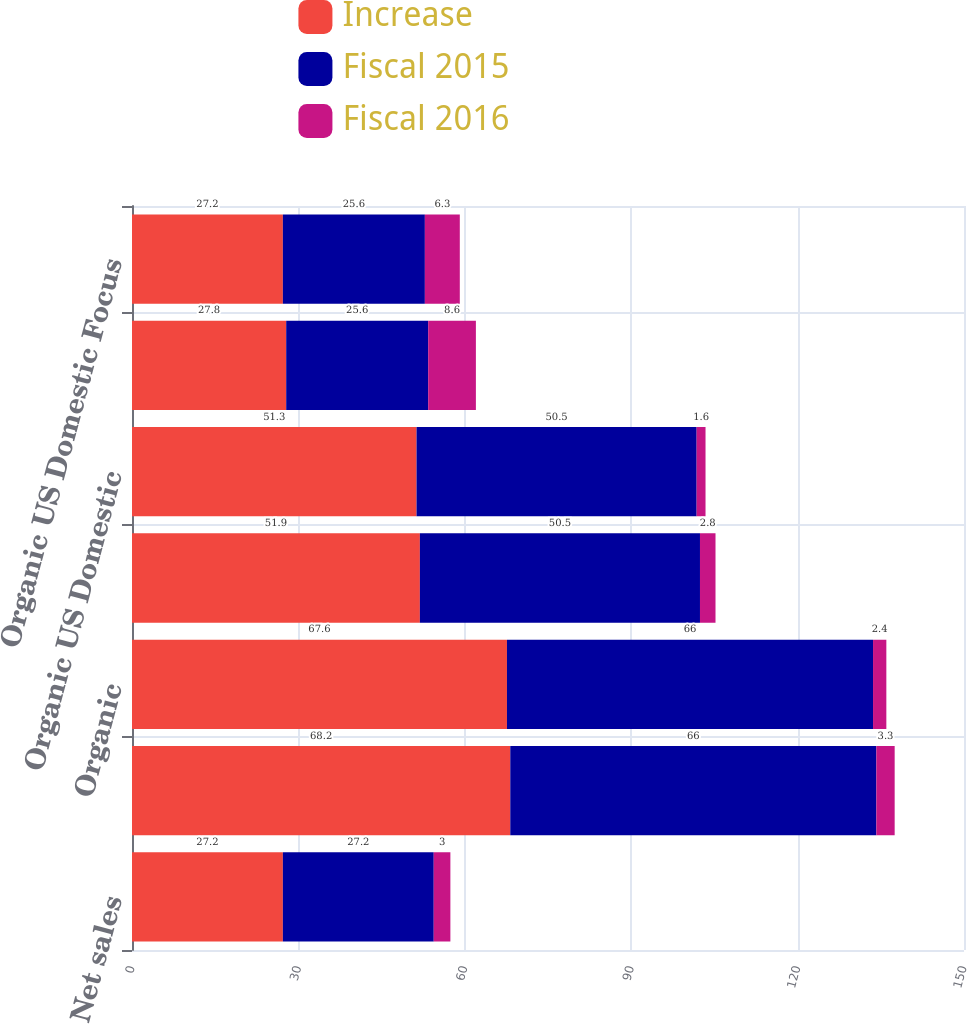Convert chart to OTSL. <chart><loc_0><loc_0><loc_500><loc_500><stacked_bar_chart><ecel><fcel>Net sales<fcel>Total<fcel>Organic<fcel>US Domestic<fcel>Organic US Domestic<fcel>US Domestic Focus Brands<fcel>Organic US Domestic Focus<nl><fcel>Increase<fcel>27.2<fcel>68.2<fcel>67.6<fcel>51.9<fcel>51.3<fcel>27.8<fcel>27.2<nl><fcel>Fiscal 2015<fcel>27.2<fcel>66<fcel>66<fcel>50.5<fcel>50.5<fcel>25.6<fcel>25.6<nl><fcel>Fiscal 2016<fcel>3<fcel>3.3<fcel>2.4<fcel>2.8<fcel>1.6<fcel>8.6<fcel>6.3<nl></chart> 